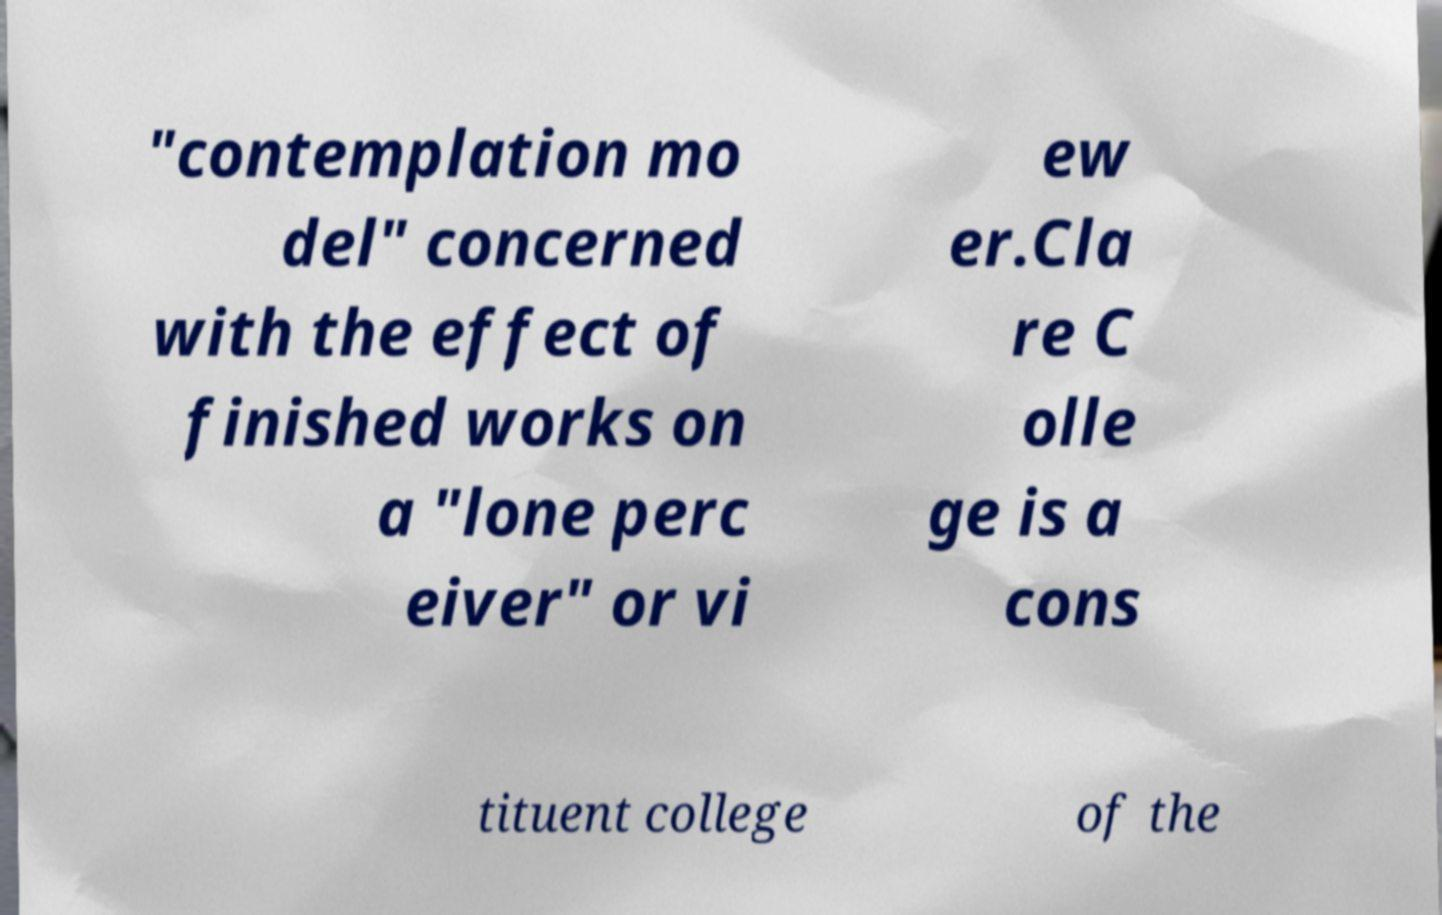What messages or text are displayed in this image? I need them in a readable, typed format. "contemplation mo del" concerned with the effect of finished works on a "lone perc eiver" or vi ew er.Cla re C olle ge is a cons tituent college of the 